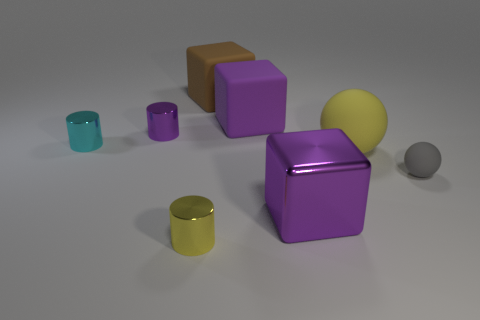Is there a pattern to the arrangement of the objects? The objects seem randomly placed, with no discernible pattern. They vary in size, color, and are scattered across the surface.  What might be the size comparison between the spheres? The yellow sphere is significantly larger than the gray sphere, which appears quite small in comparison. 